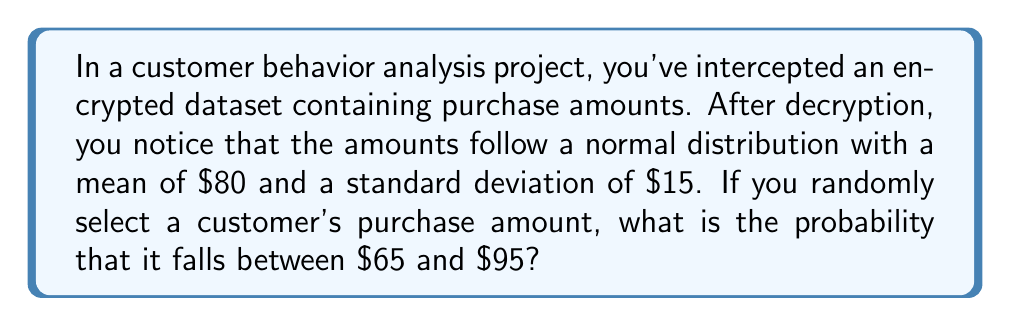Provide a solution to this math problem. To solve this problem, we need to use the properties of the normal distribution and the concept of z-scores. Let's follow these steps:

1. Identify the given information:
   - Mean (μ) = $80
   - Standard deviation (σ) = $15
   - Lower bound = $65
   - Upper bound = $95

2. Calculate the z-scores for both bounds:
   For lower bound: $z_1 = \frac{x_1 - μ}{σ} = \frac{65 - 80}{15} = -1$
   For upper bound: $z_2 = \frac{x_2 - μ}{σ} = \frac{95 - 80}{15} = 1$

3. Use the standard normal distribution table or a calculator to find the area under the curve between these z-scores:
   P(-1 < Z < 1) = P(Z < 1) - P(Z < -1)
   
   From the standard normal table:
   P(Z < 1) ≈ 0.8413
   P(Z < -1) ≈ 0.1587

4. Calculate the final probability:
   P(-1 < Z < 1) = 0.8413 - 0.1587 = 0.6826

5. Convert to percentage:
   0.6826 * 100 = 68.26%

Therefore, the probability that a randomly selected customer's purchase amount falls between $65 and $95 is approximately 68.26%.
Answer: 68.26% 